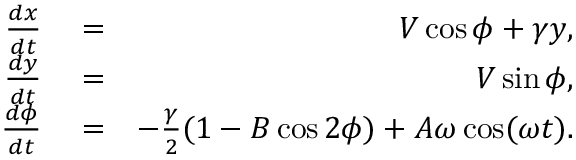Convert formula to latex. <formula><loc_0><loc_0><loc_500><loc_500>\begin{array} { r l r } { \frac { d x } { d t } } & = } & { V \cos \phi + \gamma y , } \\ { \frac { d y } { d t } } & = } & { V \sin \phi , } \\ { \frac { d \phi } { d t } } & = } & { - \frac { \gamma } { 2 } ( 1 - B \cos 2 \phi ) + A \omega \cos ( \omega t ) . } \end{array}</formula> 